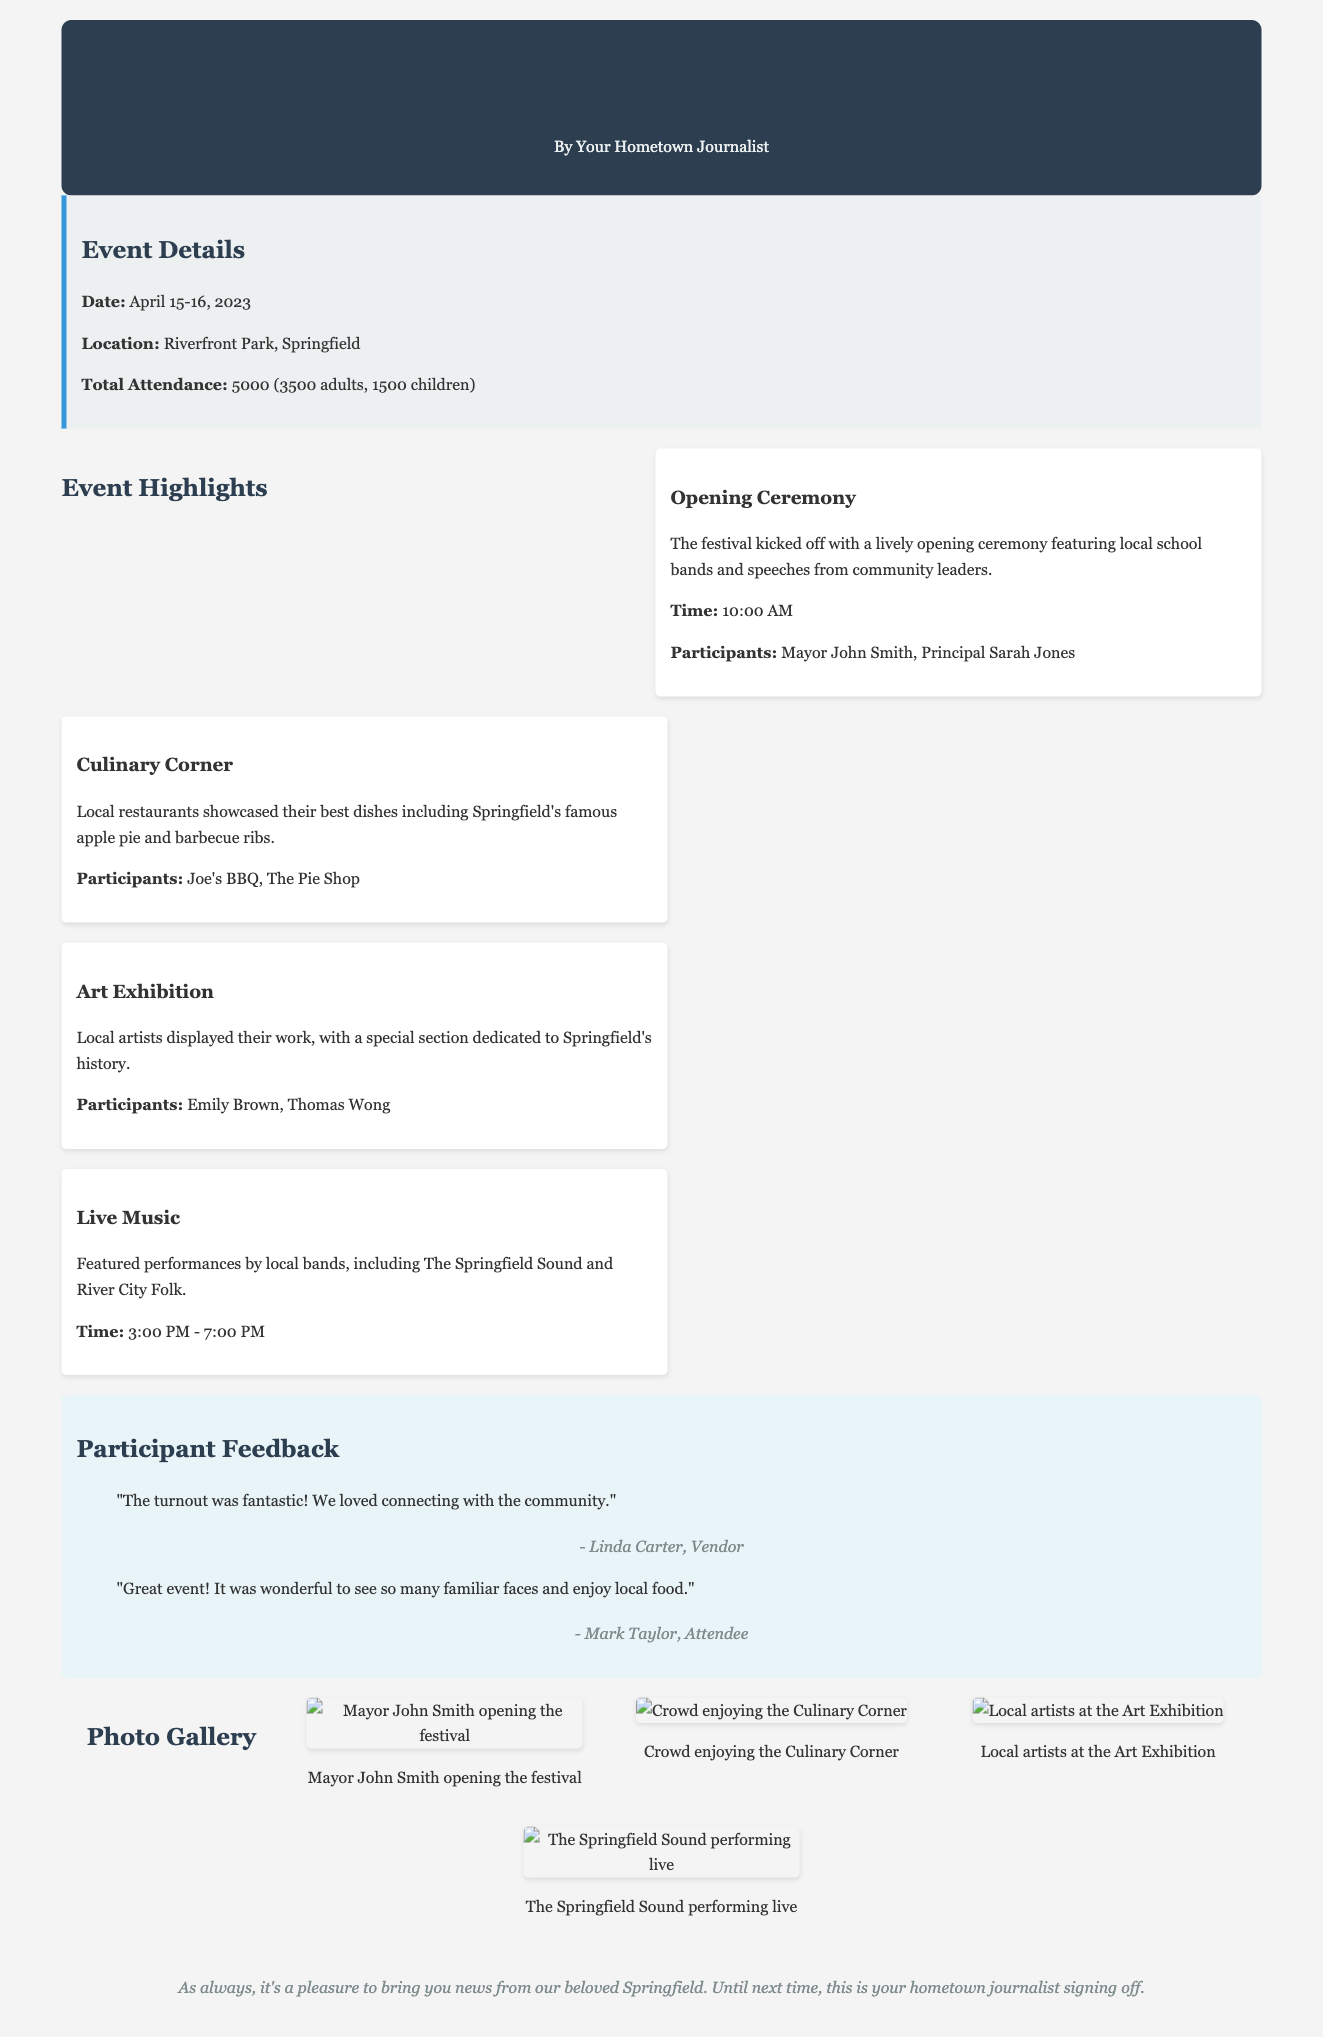what are the dates of the festival? The festival took place over two days, specifically on April 15-16, 2023.
Answer: April 15-16, 2023 how many adults attended the festival? The document states that there were 3500 adults in attendance.
Answer: 3500 who were the participants at the opening ceremony? The opening ceremony featured speeches from Mayor John Smith and Principal Sarah Jones.
Answer: Mayor John Smith, Principal Sarah Jones what local dish was highlighted at the Culinary Corner? The document mentions that Springfield's famous apple pie was showcased at the Culinary Corner.
Answer: apple pie what was one feedback remark from a vendor? Linda Carter, a vendor, commented on the fantastic turnout and connecting with the community.
Answer: "The turnout was fantastic! We loved connecting with the community." what time did the live music performances start? The live music segment began at 3:00 PM, according to the event highlights.
Answer: 3:00 PM how many children attended the festival? The document notes there were 1500 children in attendance.
Answer: 1500 which local band performed during the festival? The document mentions The Springfield Sound as one of the local bands that performed.
Answer: The Springfield Sound who showcased their work in the Art Exhibition? Artists Emily Brown and Thomas Wong displayed their work at the Art Exhibition.
Answer: Emily Brown, Thomas Wong 